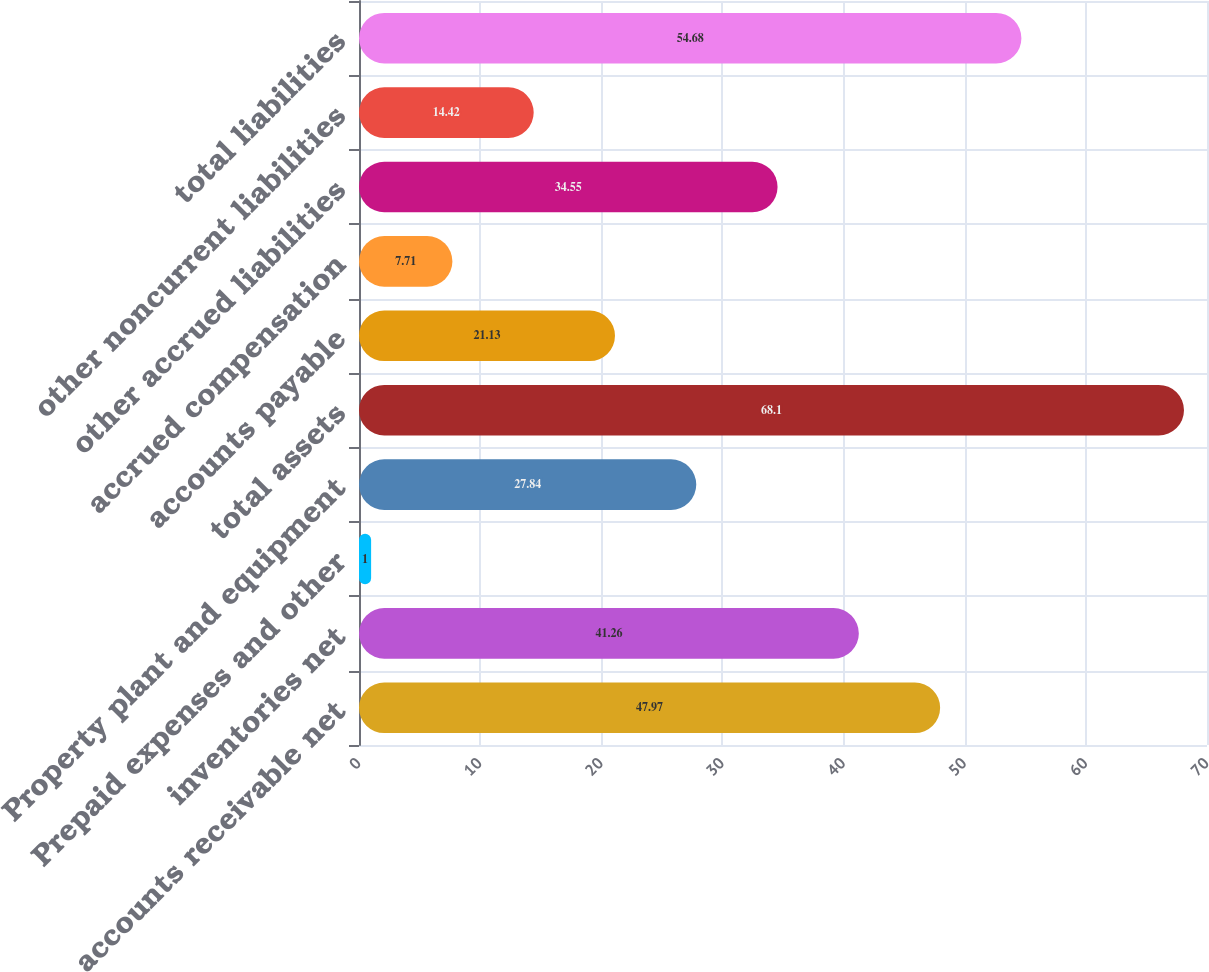<chart> <loc_0><loc_0><loc_500><loc_500><bar_chart><fcel>accounts receivable net<fcel>inventories net<fcel>Prepaid expenses and other<fcel>Property plant and equipment<fcel>total assets<fcel>accounts payable<fcel>accrued compensation<fcel>other accrued liabilities<fcel>other noncurrent liabilities<fcel>total liabilities<nl><fcel>47.97<fcel>41.26<fcel>1<fcel>27.84<fcel>68.1<fcel>21.13<fcel>7.71<fcel>34.55<fcel>14.42<fcel>54.68<nl></chart> 